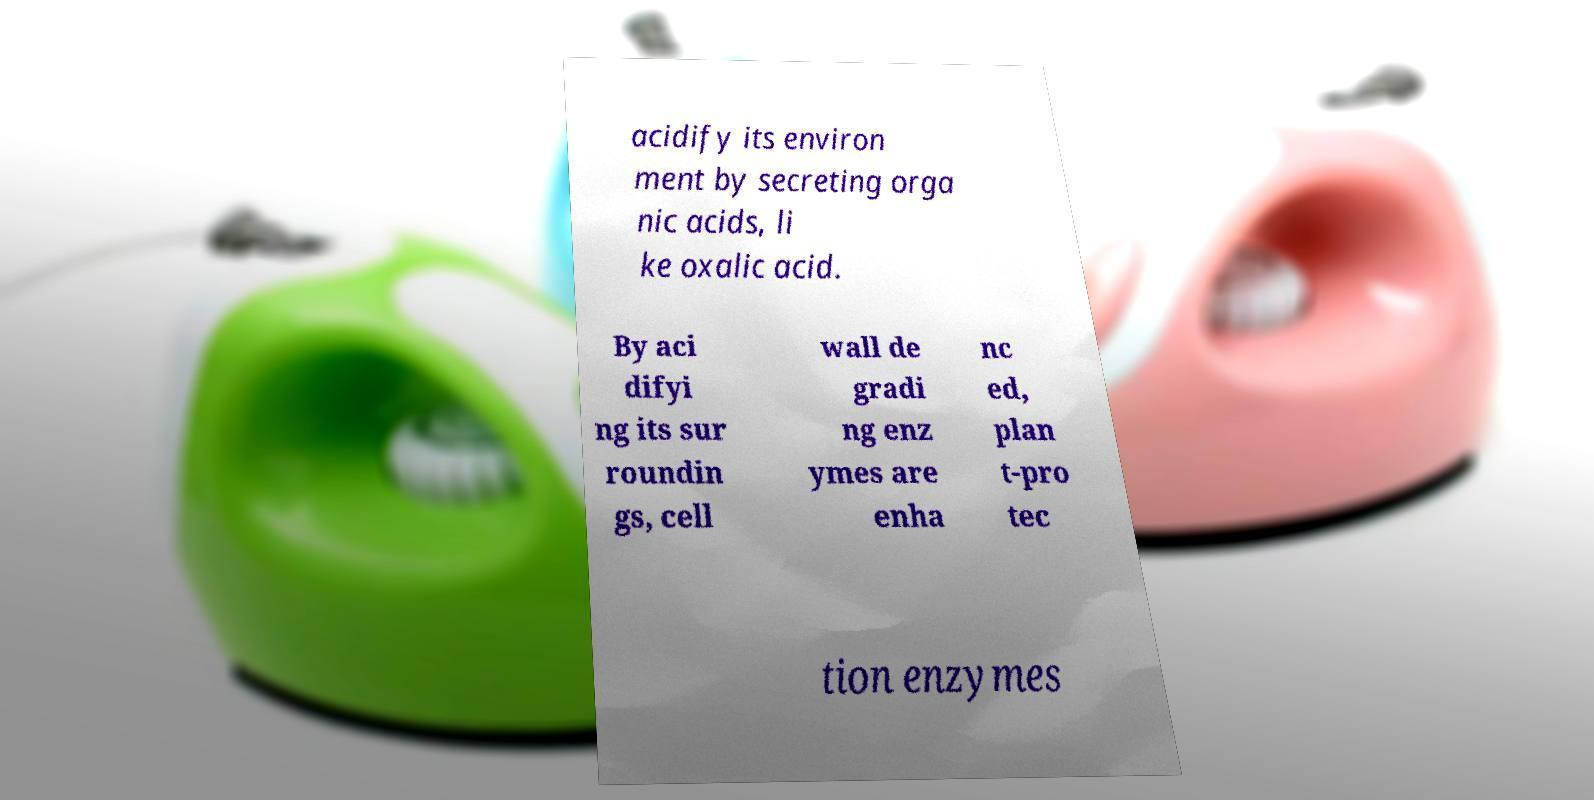Could you extract and type out the text from this image? acidify its environ ment by secreting orga nic acids, li ke oxalic acid. By aci difyi ng its sur roundin gs, cell wall de gradi ng enz ymes are enha nc ed, plan t-pro tec tion enzymes 